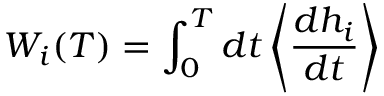Convert formula to latex. <formula><loc_0><loc_0><loc_500><loc_500>W _ { i } ( T ) = \int _ { 0 } ^ { T } d t \left \langle \frac { d h _ { i } } { d t } \right \rangle</formula> 